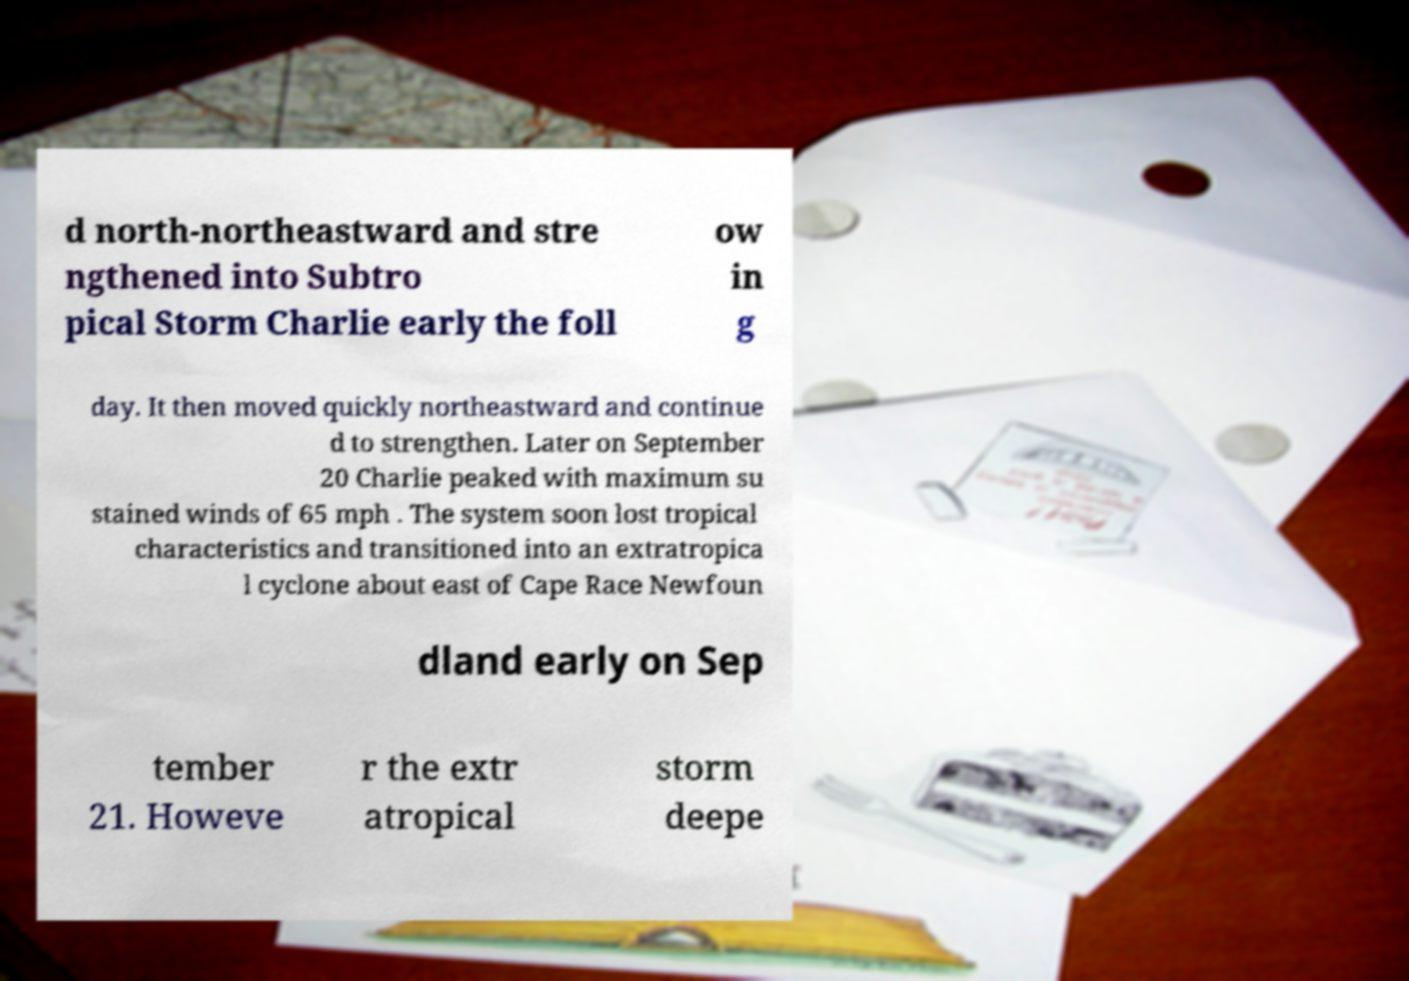Please identify and transcribe the text found in this image. d north-northeastward and stre ngthened into Subtro pical Storm Charlie early the foll ow in g day. It then moved quickly northeastward and continue d to strengthen. Later on September 20 Charlie peaked with maximum su stained winds of 65 mph . The system soon lost tropical characteristics and transitioned into an extratropica l cyclone about east of Cape Race Newfoun dland early on Sep tember 21. Howeve r the extr atropical storm deepe 